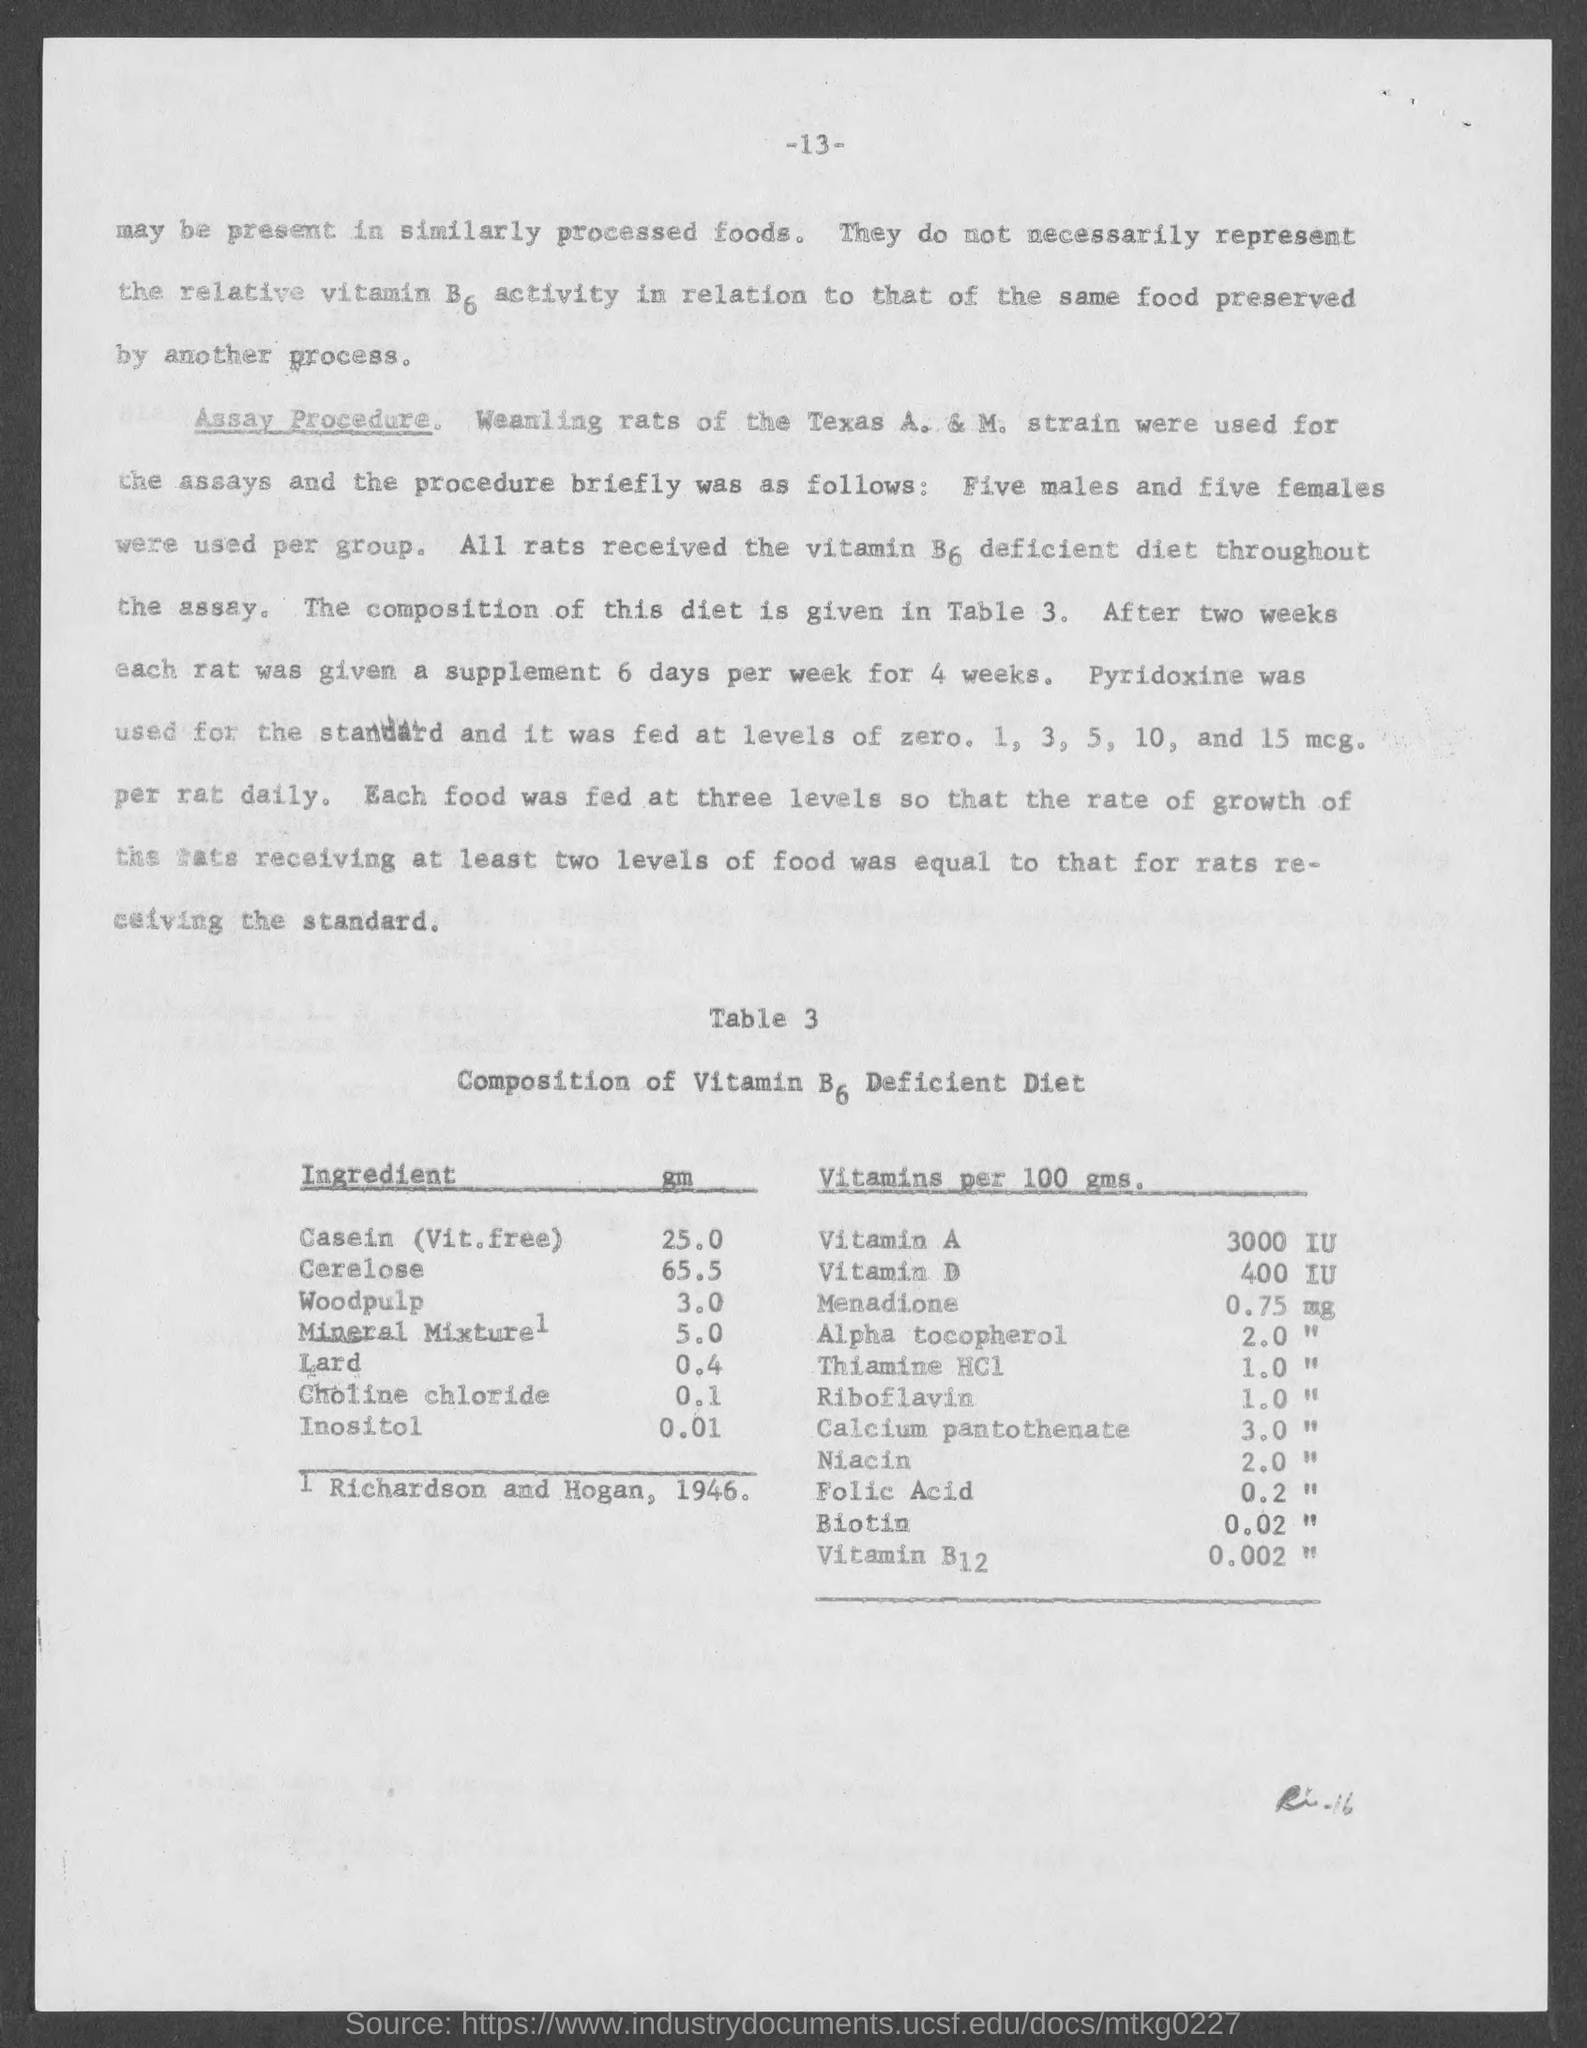Give some essential details in this illustration. The amount of B6 in Cerelose is 65.5%. The amount of vitamin B6 in inositol is 0.01. The amount of vitamin B6 in the mineral mixture is 5.0... The amount of Vitamin D in 100 grams is 400 International Units (IU). There is 0.1 milligrams of B6 in a solution of chlorine chloride. 